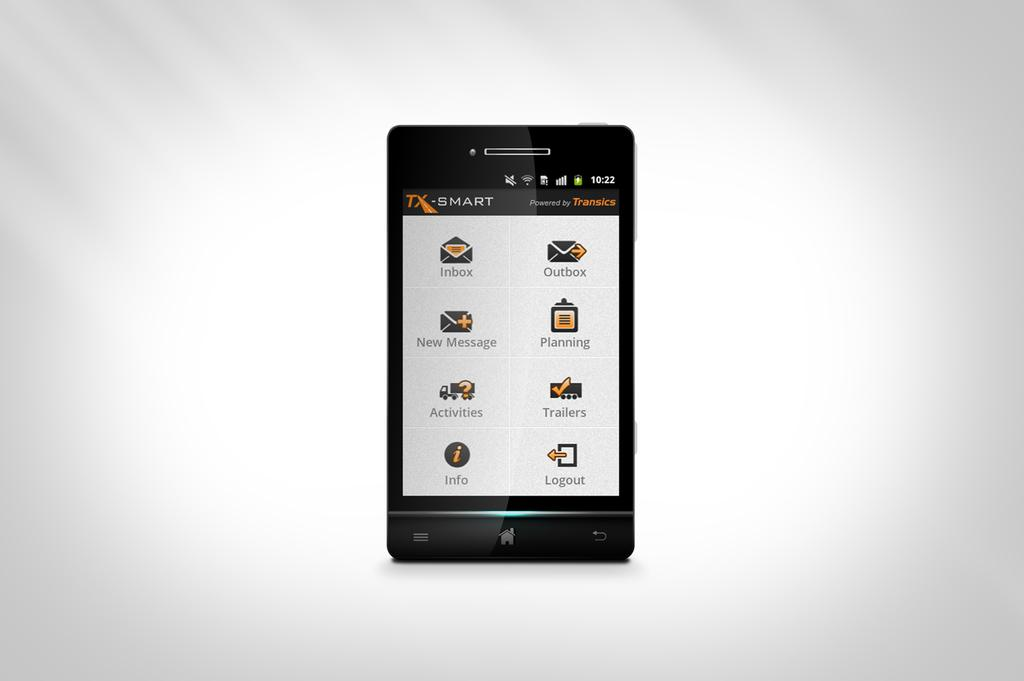<image>
Offer a succinct explanation of the picture presented. A phone is open to a menu entitled TX Smart. 